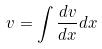Convert formula to latex. <formula><loc_0><loc_0><loc_500><loc_500>v = \int \frac { d v } { d x } d x</formula> 